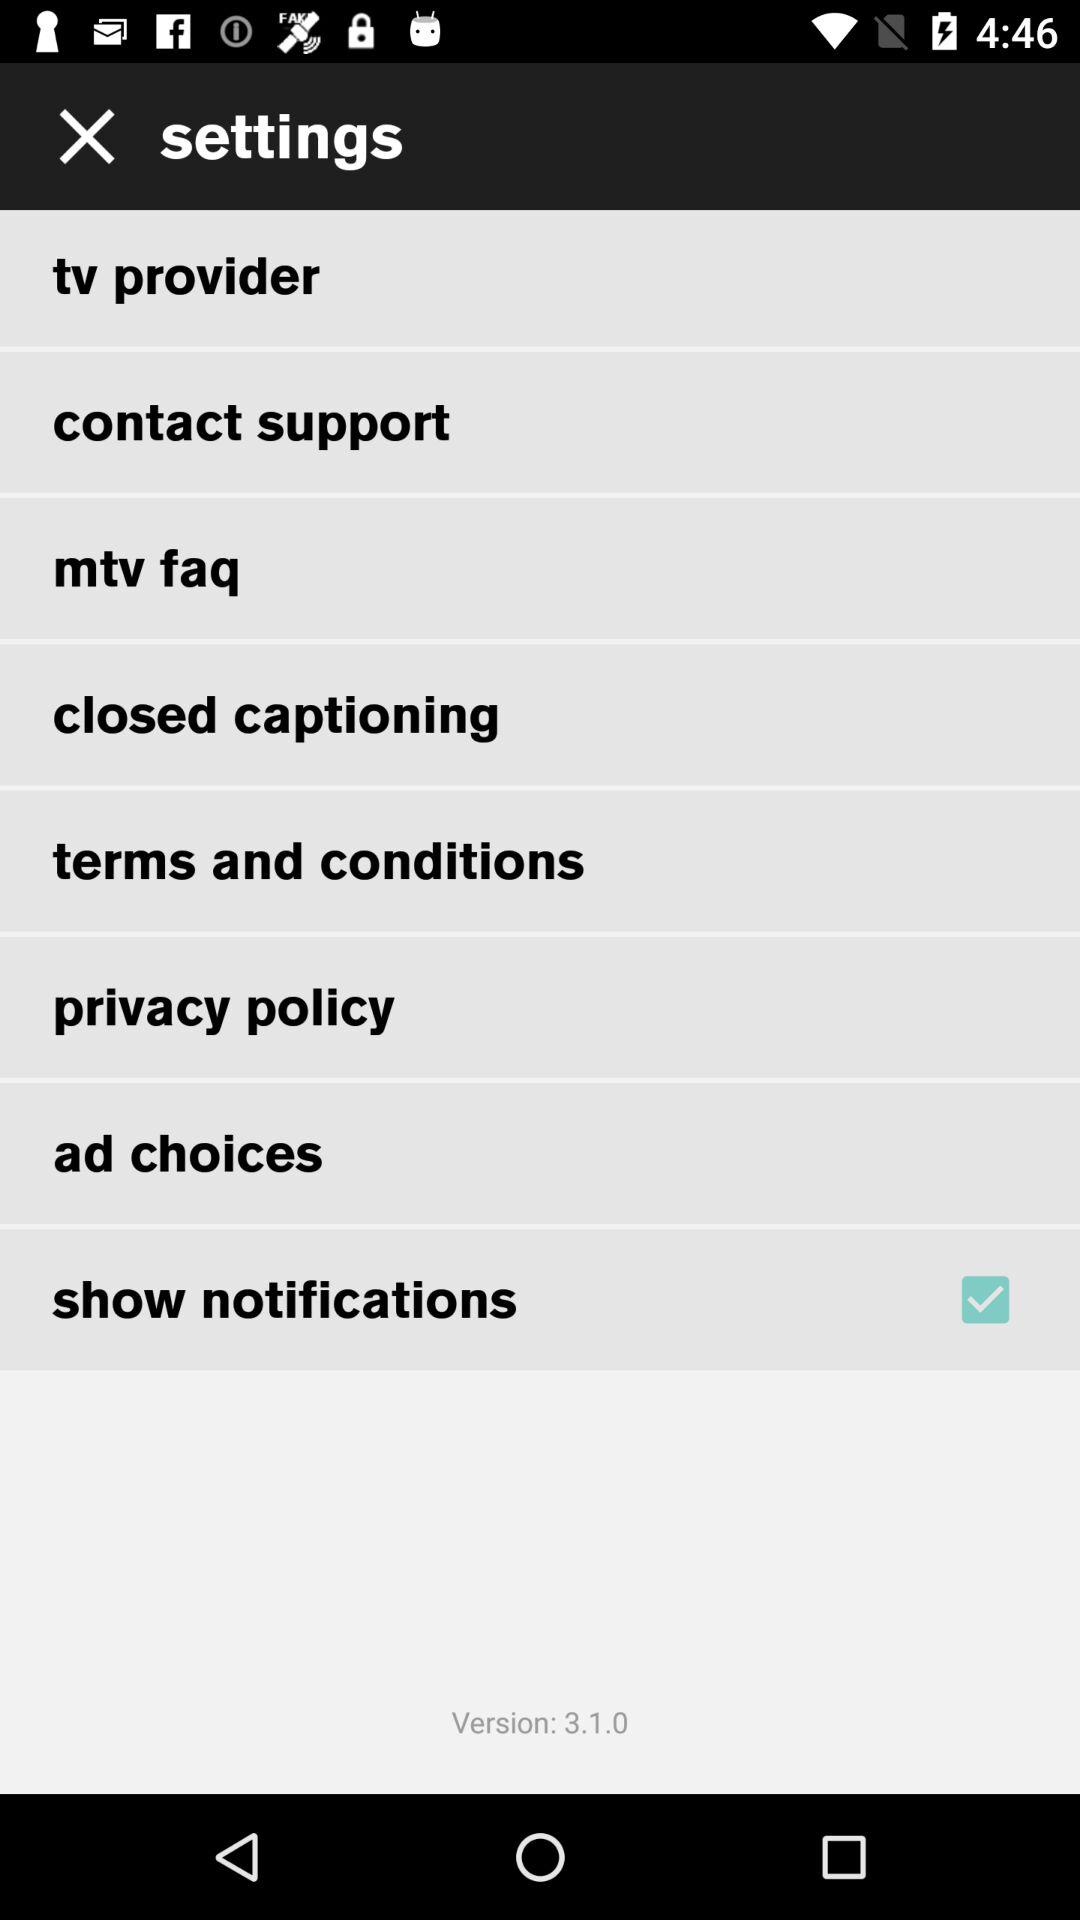What is the version of the application being used? The version is 3.1.0. 